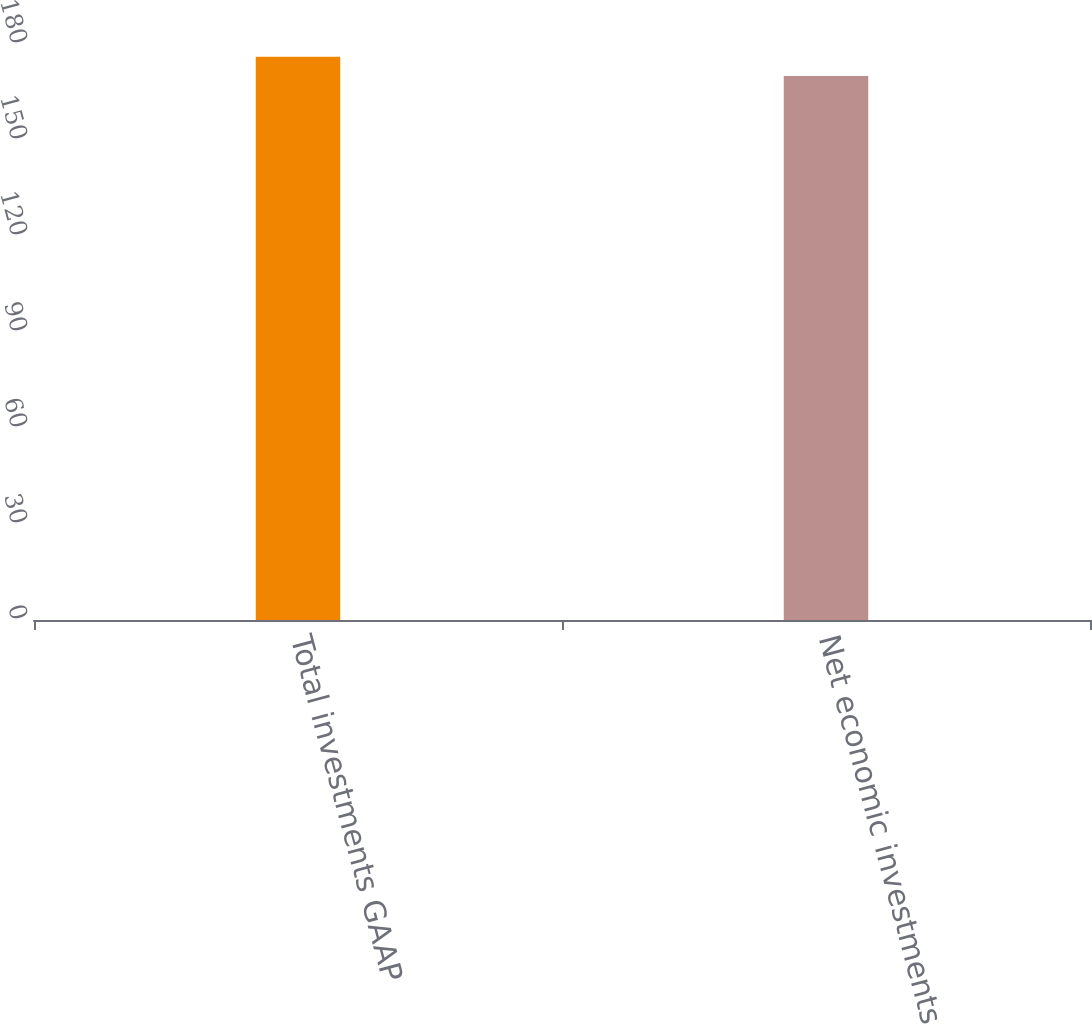<chart> <loc_0><loc_0><loc_500><loc_500><bar_chart><fcel>Total investments GAAP<fcel>Net economic investments (2)<nl><fcel>176<fcel>170<nl></chart> 